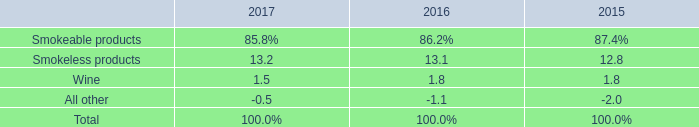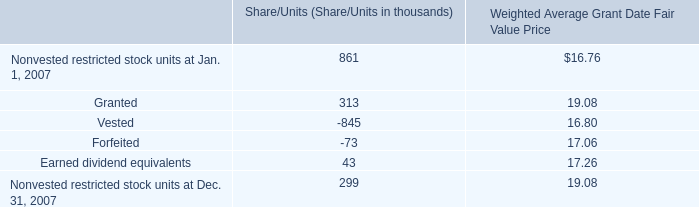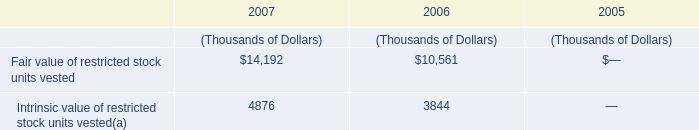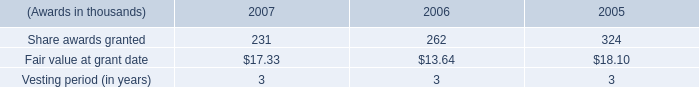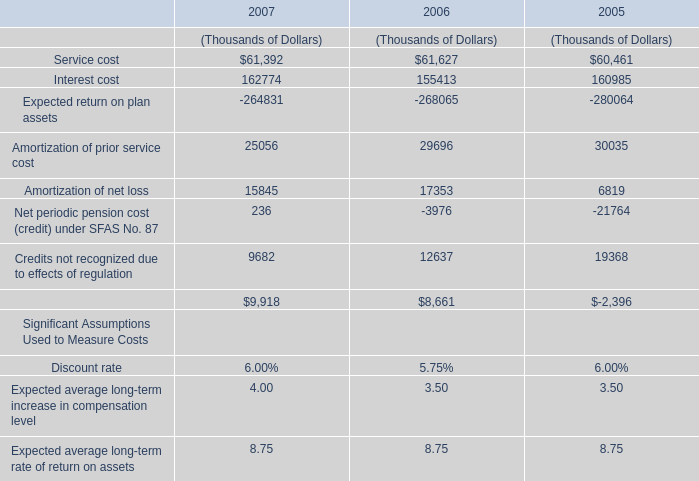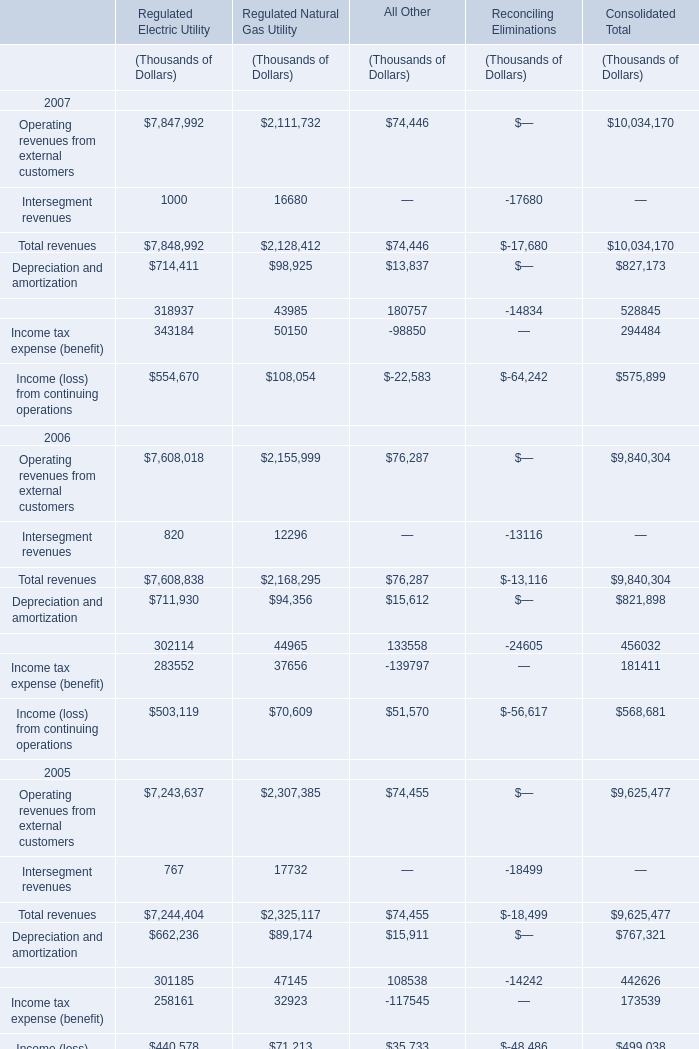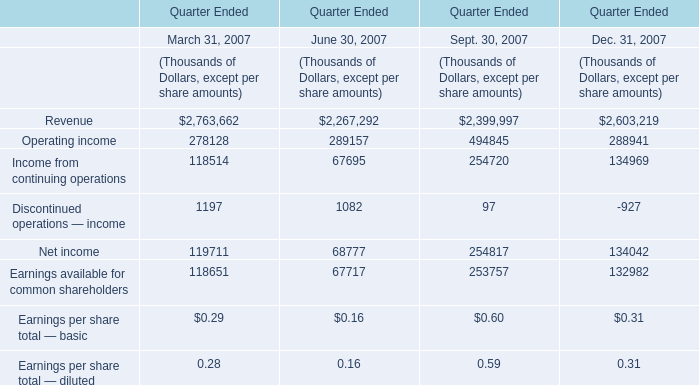what is the percentage change in the weight of smokeless products in operating income from 2016 to 2017? 
Computations: ((13.2 - 13.1) / 13.1)
Answer: 0.00763. 